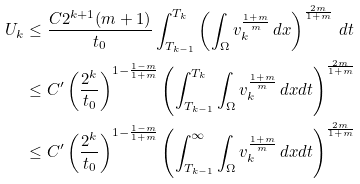Convert formula to latex. <formula><loc_0><loc_0><loc_500><loc_500>U _ { k } & \leq \frac { C 2 ^ { k + 1 } ( m + 1 ) } { t _ { 0 } } \int ^ { T _ { k } } _ { T _ { k - 1 } } \left ( \int _ { \Omega } v _ { k } ^ { \frac { 1 + m } { m } } \, d x \right ) ^ { \frac { 2 m } { 1 + m } } \, d t \\ & \leq C ^ { \prime } \left ( \frac { 2 ^ { k } } { t _ { 0 } } \right ) ^ { 1 - \frac { 1 - m } { 1 + m } } \left ( \int ^ { T _ { k } } _ { T _ { k - 1 } } \int _ { \Omega } v _ { k } ^ { \frac { 1 + m } { m } } \, d x d t \right ) ^ { \frac { 2 m } { 1 + m } } \\ & \leq C ^ { \prime } \left ( \frac { 2 ^ { k } } { t _ { 0 } } \right ) ^ { 1 - \frac { 1 - m } { 1 + m } } \left ( \int ^ { \infty } _ { T _ { k - 1 } } \int _ { \Omega } v _ { k } ^ { \frac { 1 + m } { m } } \, d x d t \right ) ^ { \frac { 2 m } { 1 + m } }</formula> 